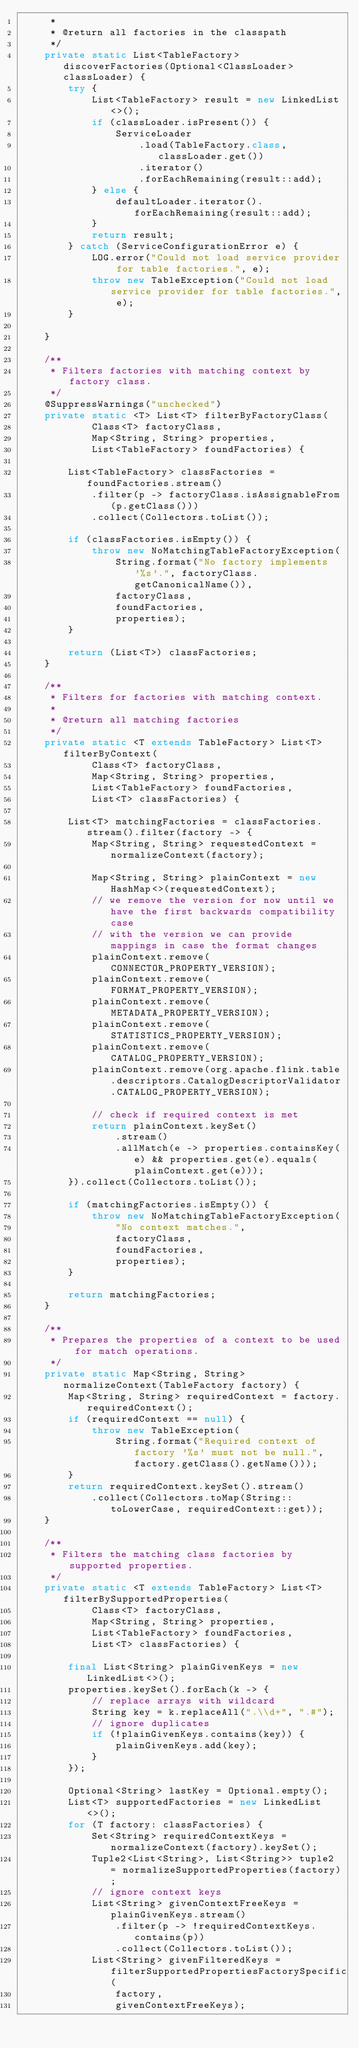Convert code to text. <code><loc_0><loc_0><loc_500><loc_500><_Java_>	 *
	 * @return all factories in the classpath
	 */
	private static List<TableFactory> discoverFactories(Optional<ClassLoader> classLoader) {
		try {
			List<TableFactory> result = new LinkedList<>();
			if (classLoader.isPresent()) {
				ServiceLoader
					.load(TableFactory.class, classLoader.get())
					.iterator()
					.forEachRemaining(result::add);
			} else {
				defaultLoader.iterator().forEachRemaining(result::add);
			}
			return result;
		} catch (ServiceConfigurationError e) {
			LOG.error("Could not load service provider for table factories.", e);
			throw new TableException("Could not load service provider for table factories.", e);
		}

	}

	/**
	 * Filters factories with matching context by factory class.
	 */
	@SuppressWarnings("unchecked")
	private static <T> List<T> filterByFactoryClass(
			Class<T> factoryClass,
			Map<String, String> properties,
			List<TableFactory> foundFactories) {

		List<TableFactory> classFactories = foundFactories.stream()
			.filter(p -> factoryClass.isAssignableFrom(p.getClass()))
			.collect(Collectors.toList());

		if (classFactories.isEmpty()) {
			throw new NoMatchingTableFactoryException(
				String.format("No factory implements '%s'.", factoryClass.getCanonicalName()),
				factoryClass,
				foundFactories,
				properties);
		}

		return (List<T>) classFactories;
	}

	/**
	 * Filters for factories with matching context.
	 *
	 * @return all matching factories
	 */
	private static <T extends TableFactory> List<T> filterByContext(
			Class<T> factoryClass,
			Map<String, String> properties,
			List<TableFactory> foundFactories,
			List<T> classFactories) {

		List<T> matchingFactories = classFactories.stream().filter(factory -> {
			Map<String, String> requestedContext = normalizeContext(factory);

			Map<String, String> plainContext = new HashMap<>(requestedContext);
			// we remove the version for now until we have the first backwards compatibility case
			// with the version we can provide mappings in case the format changes
			plainContext.remove(CONNECTOR_PROPERTY_VERSION);
			plainContext.remove(FORMAT_PROPERTY_VERSION);
			plainContext.remove(METADATA_PROPERTY_VERSION);
			plainContext.remove(STATISTICS_PROPERTY_VERSION);
			plainContext.remove(CATALOG_PROPERTY_VERSION);
			plainContext.remove(org.apache.flink.table.descriptors.CatalogDescriptorValidator.CATALOG_PROPERTY_VERSION);

			// check if required context is met
			return plainContext.keySet()
				.stream()
				.allMatch(e -> properties.containsKey(e) && properties.get(e).equals(plainContext.get(e)));
		}).collect(Collectors.toList());

		if (matchingFactories.isEmpty()) {
			throw new NoMatchingTableFactoryException(
				"No context matches.",
				factoryClass,
				foundFactories,
				properties);
		}

		return matchingFactories;
	}

	/**
	 * Prepares the properties of a context to be used for match operations.
	 */
	private static Map<String, String> normalizeContext(TableFactory factory) {
		Map<String, String> requiredContext = factory.requiredContext();
		if (requiredContext == null) {
			throw new TableException(
				String.format("Required context of factory '%s' must not be null.", factory.getClass().getName()));
		}
		return requiredContext.keySet().stream()
			.collect(Collectors.toMap(String::toLowerCase, requiredContext::get));
	}

	/**
	 * Filters the matching class factories by supported properties.
	 */
	private static <T extends TableFactory> List<T> filterBySupportedProperties(
			Class<T> factoryClass,
			Map<String, String> properties,
			List<TableFactory> foundFactories,
			List<T> classFactories) {

		final List<String> plainGivenKeys = new LinkedList<>();
		properties.keySet().forEach(k -> {
			// replace arrays with wildcard
			String key = k.replaceAll(".\\d+", ".#");
			// ignore duplicates
			if (!plainGivenKeys.contains(key)) {
				plainGivenKeys.add(key);
			}
		});

		Optional<String> lastKey = Optional.empty();
		List<T> supportedFactories = new LinkedList<>();
		for (T factory: classFactories) {
			Set<String> requiredContextKeys = normalizeContext(factory).keySet();
			Tuple2<List<String>, List<String>> tuple2 = normalizeSupportedProperties(factory);
			// ignore context keys
			List<String> givenContextFreeKeys = plainGivenKeys.stream()
				.filter(p -> !requiredContextKeys.contains(p))
				.collect(Collectors.toList());
			List<String> givenFilteredKeys = filterSupportedPropertiesFactorySpecific(
				factory,
				givenContextFreeKeys);
</code> 